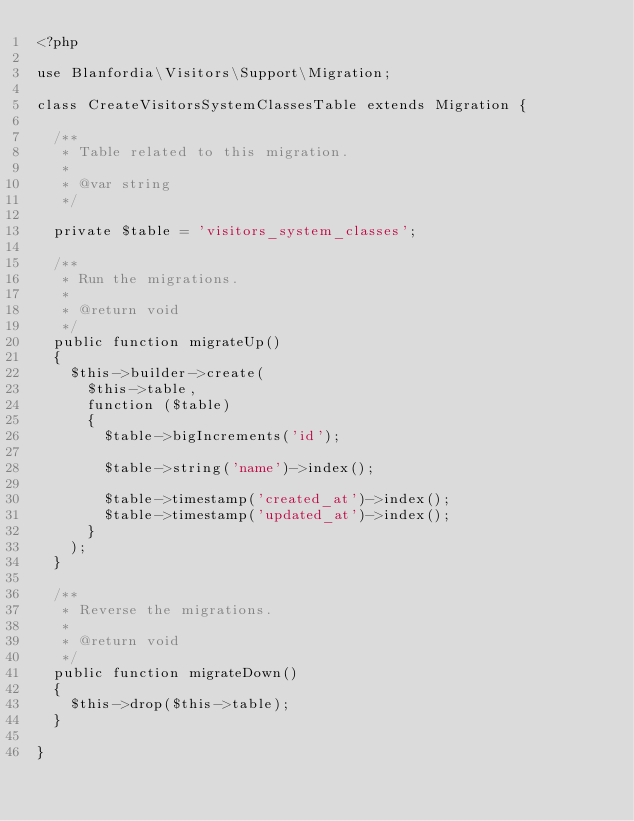Convert code to text. <code><loc_0><loc_0><loc_500><loc_500><_PHP_><?php

use Blanfordia\Visitors\Support\Migration;

class CreateVisitorsSystemClassesTable extends Migration {

	/**
	 * Table related to this migration.
	 *
	 * @var string
	 */

	private $table = 'visitors_system_classes';

	/**
	 * Run the migrations.
	 *
	 * @return void
	 */
	public function migrateUp()
	{
		$this->builder->create(
			$this->table,
			function ($table)
			{
				$table->bigIncrements('id');

				$table->string('name')->index();

				$table->timestamp('created_at')->index();
				$table->timestamp('updated_at')->index();
			}
		);
	}

	/**
	 * Reverse the migrations.
	 *
	 * @return void
	 */
	public function migrateDown()
	{
		$this->drop($this->table);
	}

}
</code> 